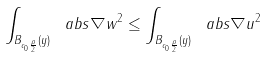<formula> <loc_0><loc_0><loc_500><loc_500>\int _ { B _ { c _ { 0 } \frac { \rho } { 2 } } ( y ) } \ a b s { \nabla w } ^ { 2 } \leq \int _ { B _ { c _ { 0 } \frac { \rho } { 2 } } ( y ) } \ a b s { \nabla u } ^ { 2 }</formula> 